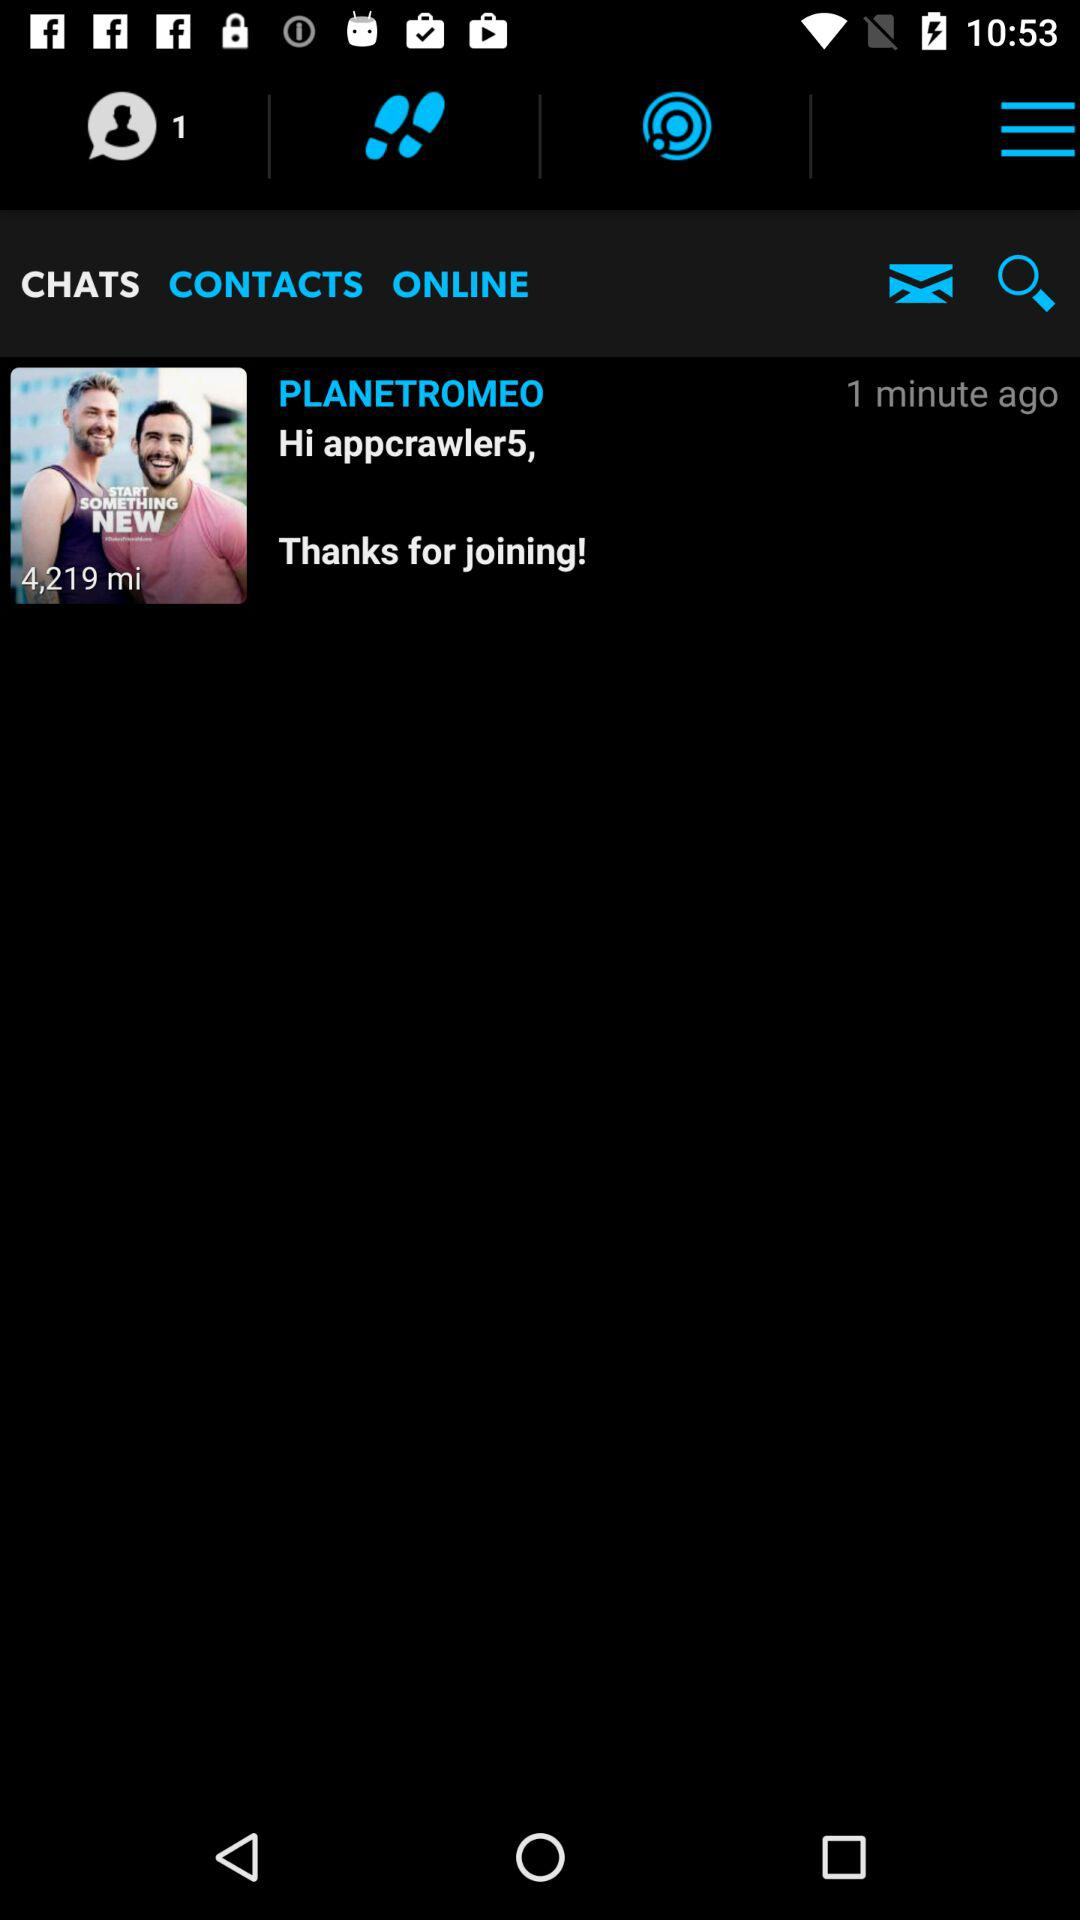Which tab is selected? The selected tab is "CHATS". 